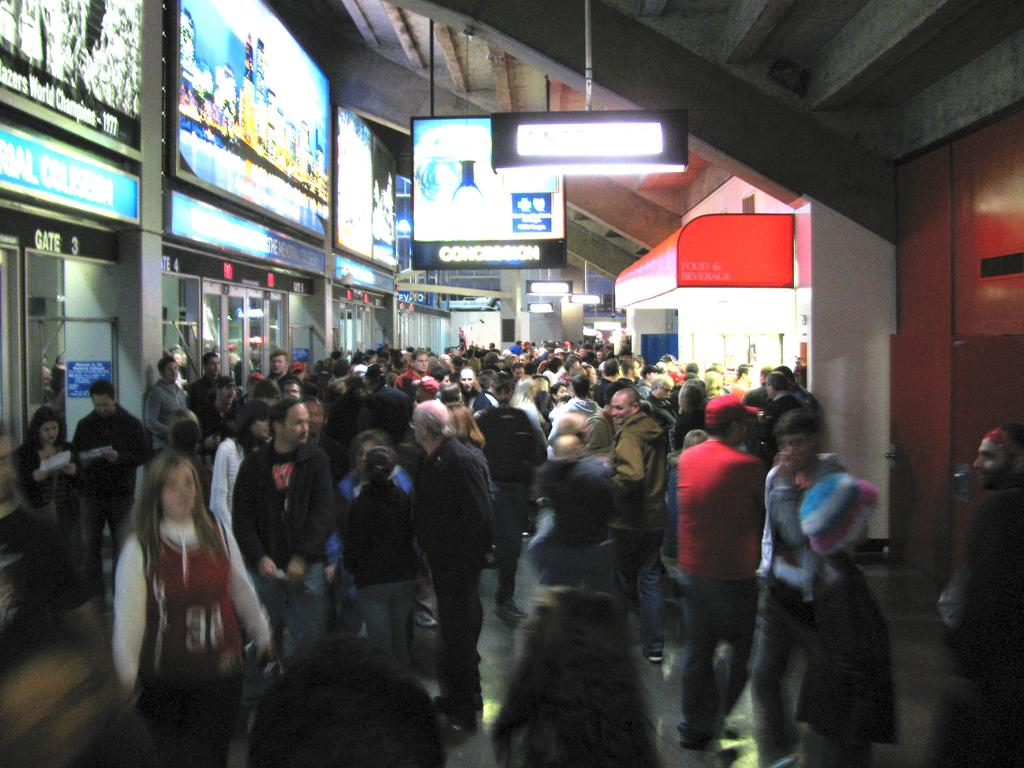What are the persons in the image doing? The persons in the image are walking on the floor. What can be seen hanging from the roof in the image? There are boards and lights hanging from the roof in the image. What is visible behind the persons in the image? There are shops visible behind the persons in the image. What type of fuel is being used by the bean in the image? There is no bean present in the image, and therefore no fuel usage can be observed. 